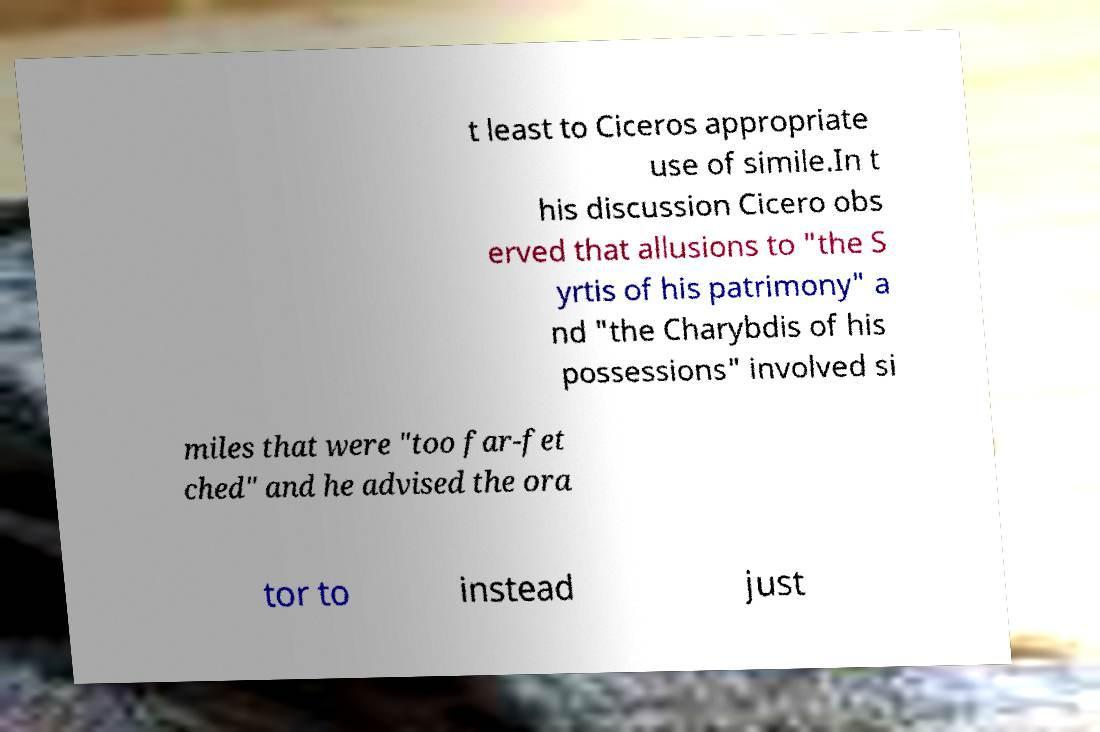Could you assist in decoding the text presented in this image and type it out clearly? t least to Ciceros appropriate use of simile.In t his discussion Cicero obs erved that allusions to "the S yrtis of his patrimony" a nd "the Charybdis of his possessions" involved si miles that were "too far-fet ched" and he advised the ora tor to instead just 